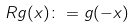<formula> <loc_0><loc_0><loc_500><loc_500>R g ( x ) \colon = g ( - x )</formula> 